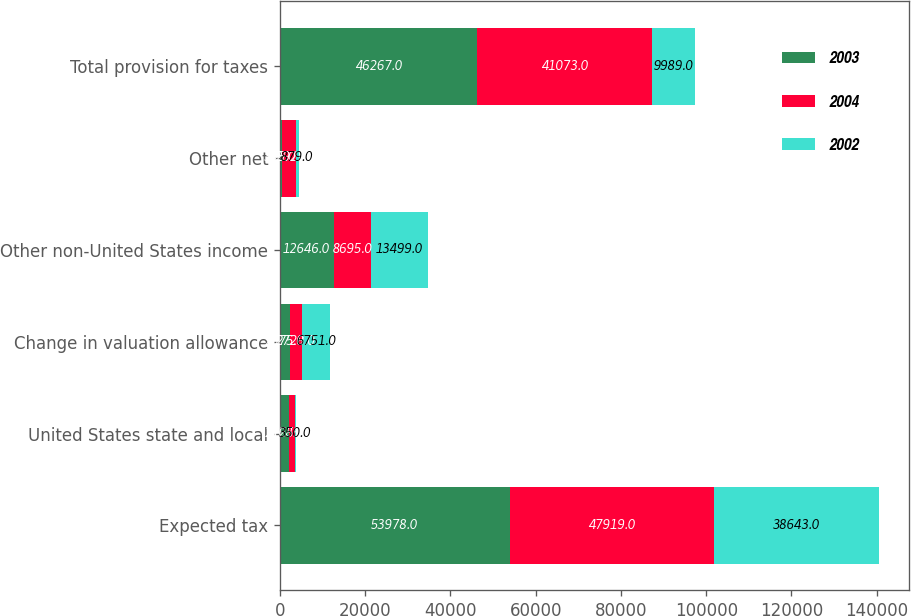<chart> <loc_0><loc_0><loc_500><loc_500><stacked_bar_chart><ecel><fcel>Expected tax<fcel>United States state and local<fcel>Change in valuation allowance<fcel>Other non-United States income<fcel>Other net<fcel>Total provision for taxes<nl><fcel>2003<fcel>53978<fcel>2165<fcel>2375<fcel>12646<fcel>395<fcel>46267<nl><fcel>2004<fcel>47919<fcel>1285<fcel>2728<fcel>8695<fcel>3292<fcel>41073<nl><fcel>2002<fcel>38643<fcel>350<fcel>6751<fcel>13499<fcel>879<fcel>9989<nl></chart> 